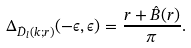Convert formula to latex. <formula><loc_0><loc_0><loc_500><loc_500>\Delta _ { \hat { D } _ { l } ( k ; r ) } ( - \epsilon , \epsilon ) = \frac { r + \hat { B } ( r ) } { \pi } .</formula> 